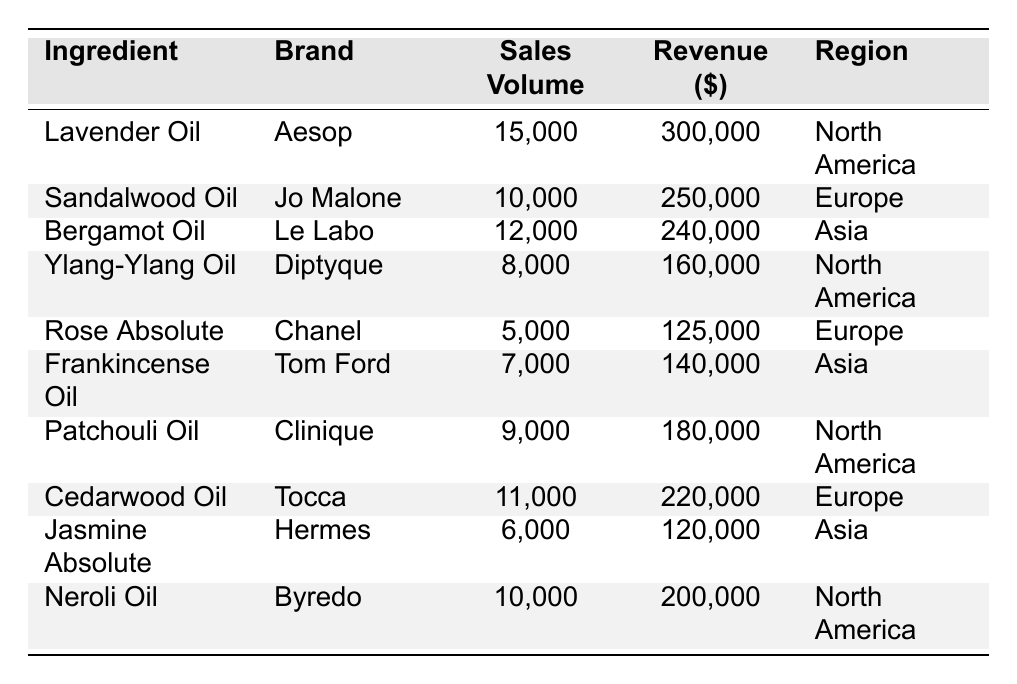What is the total sales volume of all ingredients listed? To find the total sales volume, we need to sum up all the sales volumes from each ingredient: 15,000 + 10,000 + 12,000 + 8,000 + 5,000 + 7,000 + 9,000 + 11,000 + 6,000 + 10,000 = 87,000
Answer: 87,000 Which ingredient generated the highest revenue? Looking at the revenue column, Lavender Oil generated the highest revenue at $300,000
Answer: Lavender Oil How many ingredients have a sales volume greater than 10,000? Analyzing the sales volume column, we see Lavender Oil (15,000), Bergamot Oil (12,000), and Cedarwood Oil (11,000) have sales volumes greater than 10,000, making a total of 3
Answer: 3 What is the average revenue of the ingredients from North America? The ingredients from North America are Lavender Oil ($300,000), Ylang-Ylang Oil ($160,000), Patchouli Oil ($180,000), and Neroli Oil ($200,000). Their total revenue is 300,000 + 160,000 + 180,000 + 200,000 = 840,000, and there are 4 ingredients, so the average revenue is 840,000 / 4 = 210,000
Answer: 210,000 Is there an ingredient that has both the lowest sales volume and revenue? Scanning through the table, Rose Absolute has the lowest sales volume of 5,000 and also the lowest revenue of $125,000
Answer: Yes Which region has the highest total revenue from the ingredients? The total revenue from each region: North America = 300,000 + 160,000 + 180,000 + 200,000 = 840,000; Europe = 250,000 + 125,000 + 220,000 = 595,000; Asia = 240,000 + 140,000 + 120,000 = 500,000. North America has the highest revenue
Answer: North America What is the difference in sales volume between the best-selling ingredient and the one with the lowest sales volume? The best-selling ingredient is Lavender Oil (15,000) and the lowest is Rose Absolute (5,000). The difference is 15,000 - 5,000 = 10,000
Answer: 10,000 How many ingredients are associated with the brand "Jo Malone"? The brand "Jo Malone" corresponds to only one ingredient listed in the table, which is Sandalwood Oil
Answer: 1 What percentage of total sales volume comes from Asian ingredients? The total sales volume for Asian ingredients is 12,000 (Bergamot Oil) + 7,000 (Frankincense Oil) + 6,000 (Jasmine Absolute) = 25,000. The percentage is (25,000 / 87,000) * 100 = 28.74%
Answer: 28.74% 